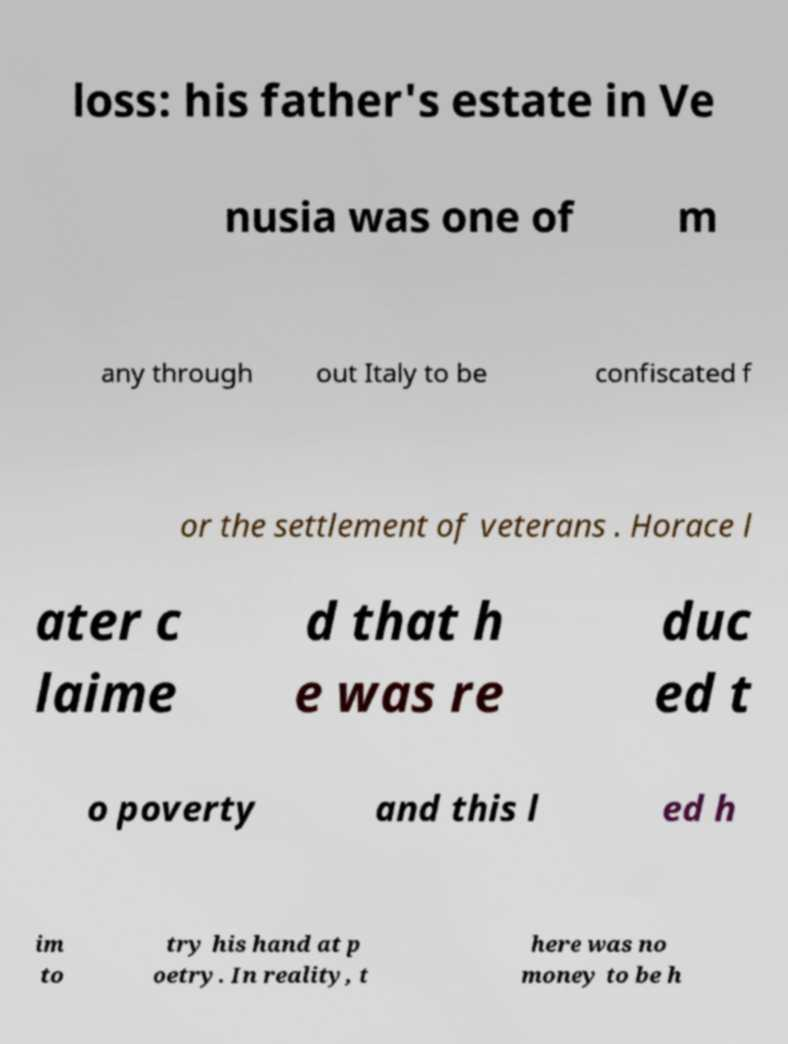Please read and relay the text visible in this image. What does it say? loss: his father's estate in Ve nusia was one of m any through out Italy to be confiscated f or the settlement of veterans . Horace l ater c laime d that h e was re duc ed t o poverty and this l ed h im to try his hand at p oetry. In reality, t here was no money to be h 